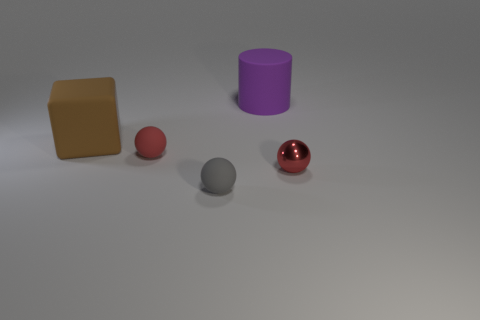Add 2 large purple rubber things. How many objects exist? 7 Subtract all spheres. How many objects are left? 2 Subtract 0 purple cubes. How many objects are left? 5 Subtract all small green shiny cylinders. Subtract all blocks. How many objects are left? 4 Add 3 tiny red balls. How many tiny red balls are left? 5 Add 5 red matte objects. How many red matte objects exist? 6 